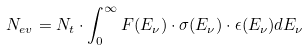<formula> <loc_0><loc_0><loc_500><loc_500>N _ { e v } = N _ { t } \cdot \int _ { 0 } ^ { \infty } F ( E _ { \nu } ) \cdot \sigma ( E _ { \nu } ) \cdot \epsilon ( E _ { \nu } ) d E _ { \nu }</formula> 